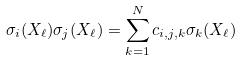Convert formula to latex. <formula><loc_0><loc_0><loc_500><loc_500>\sigma _ { i } ( X _ { \ell } ) \sigma _ { j } ( X _ { \ell } ) = \sum _ { k = 1 } ^ { N } c _ { i , j , k } \sigma _ { k } ( X _ { \ell } )</formula> 